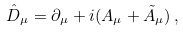<formula> <loc_0><loc_0><loc_500><loc_500>\hat { D } _ { \mu } = \partial _ { \mu } + i ( { A } _ { \mu } + { \tilde { A } } _ { \mu } ) \, ,</formula> 